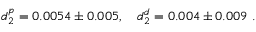Convert formula to latex. <formula><loc_0><loc_0><loc_500><loc_500>d _ { 2 } ^ { p } = 0 . 0 0 5 4 \pm 0 . 0 0 5 , d _ { 2 } ^ { d } = 0 . 0 0 4 \pm 0 . 0 0 9 \ .</formula> 